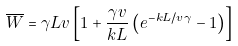<formula> <loc_0><loc_0><loc_500><loc_500>\overline { W } = \gamma L v \left [ 1 + \frac { \gamma v } { k L } \left ( e ^ { - k L / v \gamma } - 1 \right ) \right ]</formula> 